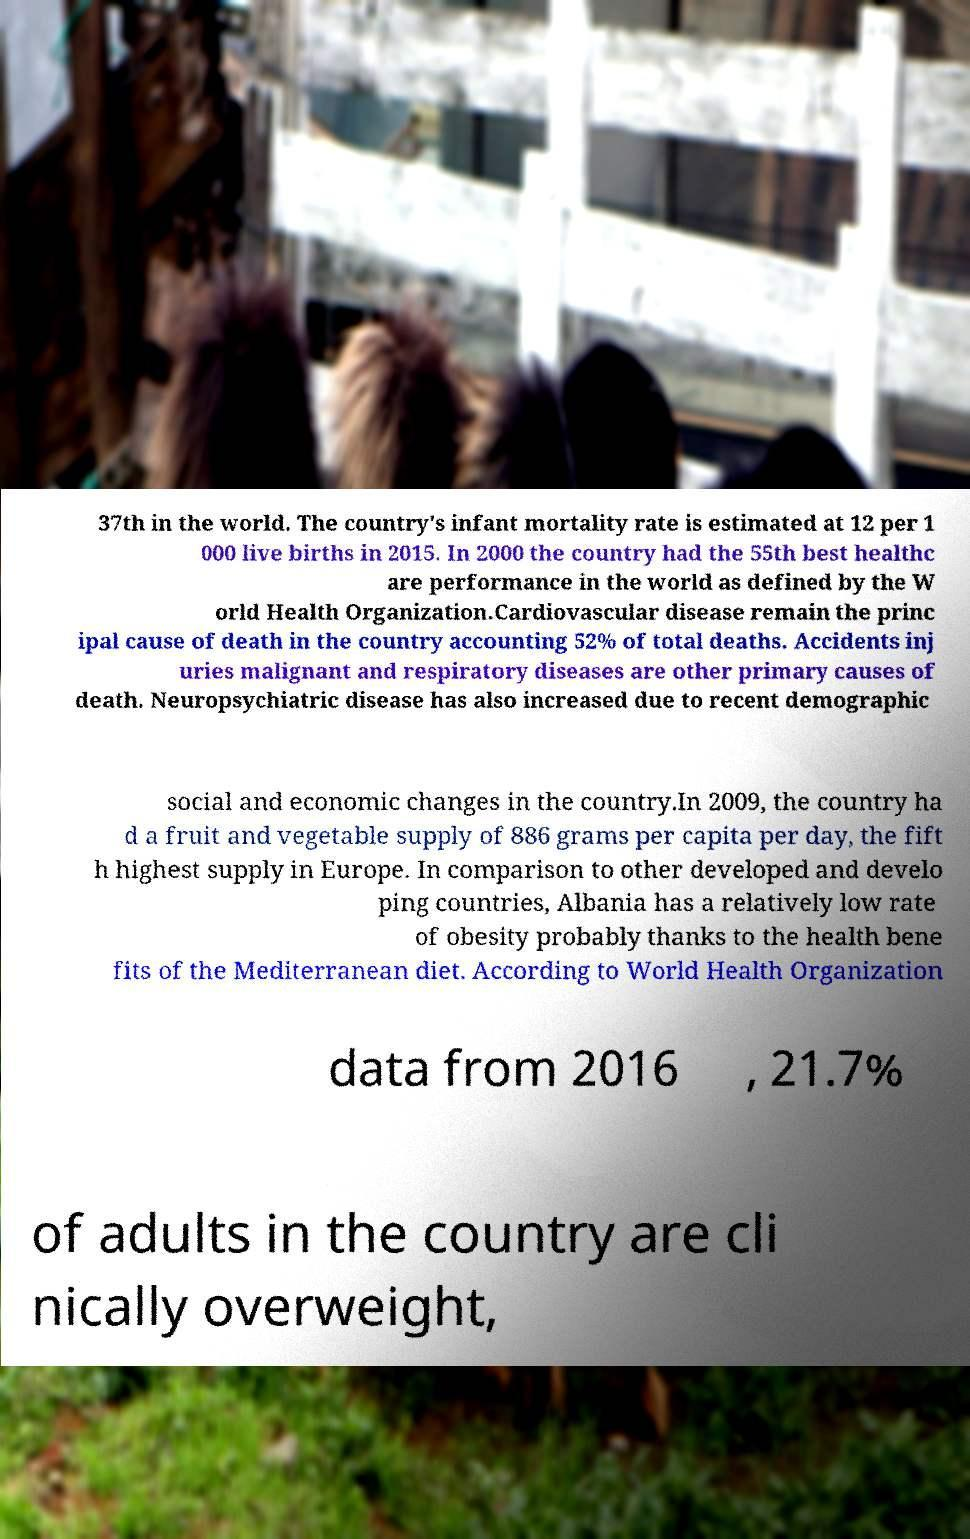For documentation purposes, I need the text within this image transcribed. Could you provide that? 37th in the world. The country's infant mortality rate is estimated at 12 per 1 000 live births in 2015. In 2000 the country had the 55th best healthc are performance in the world as defined by the W orld Health Organization.Cardiovascular disease remain the princ ipal cause of death in the country accounting 52% of total deaths. Accidents inj uries malignant and respiratory diseases are other primary causes of death. Neuropsychiatric disease has also increased due to recent demographic social and economic changes in the country.In 2009, the country ha d a fruit and vegetable supply of 886 grams per capita per day, the fift h highest supply in Europe. In comparison to other developed and develo ping countries, Albania has a relatively low rate of obesity probably thanks to the health bene fits of the Mediterranean diet. According to World Health Organization data from 2016 , 21.7% of adults in the country are cli nically overweight, 